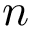Convert formula to latex. <formula><loc_0><loc_0><loc_500><loc_500>{ n }</formula> 